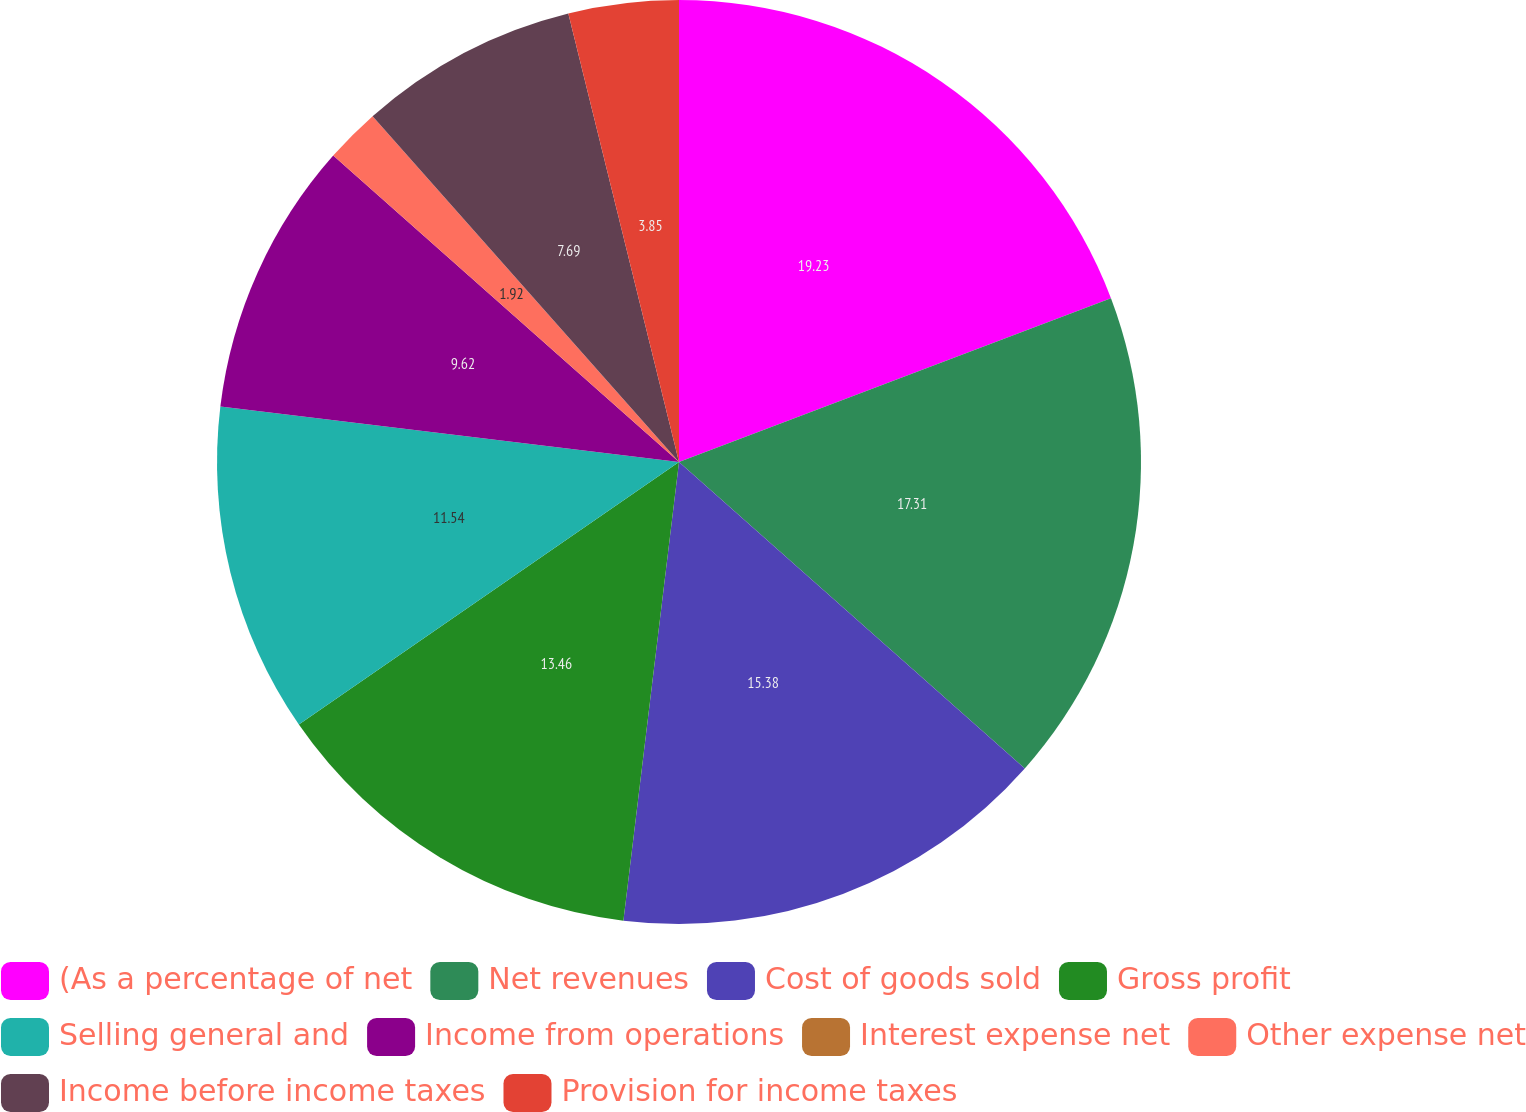Convert chart to OTSL. <chart><loc_0><loc_0><loc_500><loc_500><pie_chart><fcel>(As a percentage of net<fcel>Net revenues<fcel>Cost of goods sold<fcel>Gross profit<fcel>Selling general and<fcel>Income from operations<fcel>Interest expense net<fcel>Other expense net<fcel>Income before income taxes<fcel>Provision for income taxes<nl><fcel>19.23%<fcel>17.31%<fcel>15.38%<fcel>13.46%<fcel>11.54%<fcel>9.62%<fcel>0.0%<fcel>1.92%<fcel>7.69%<fcel>3.85%<nl></chart> 